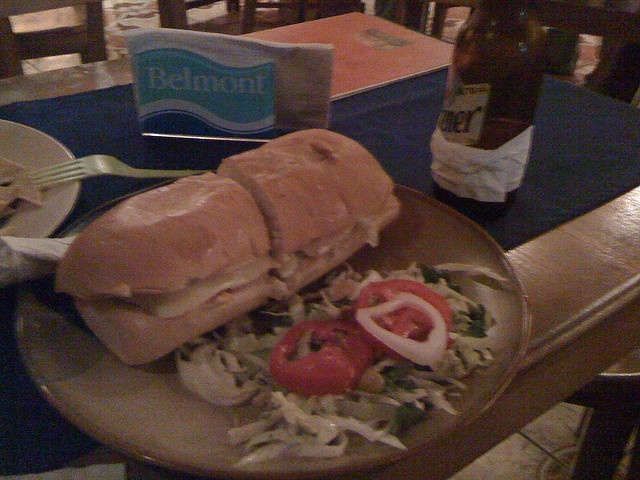Describe the objects in this image and their specific colors. I can see dining table in black, maroon, and gray tones, sandwich in maroon and brown tones, dining table in maroon, black, navy, and gray tones, bottle in maroon, black, and gray tones, and chair in maroon, black, and tan tones in this image. 